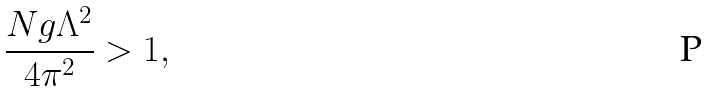<formula> <loc_0><loc_0><loc_500><loc_500>\frac { N g \Lambda ^ { 2 } } { 4 \pi ^ { 2 } } > 1 ,</formula> 